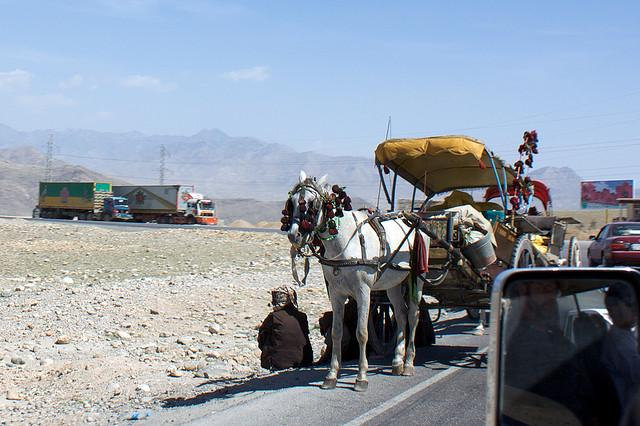In which continent is this road located?

Choices:
A) europe
B) eastern asia
C) africa
D) western asia western asia 